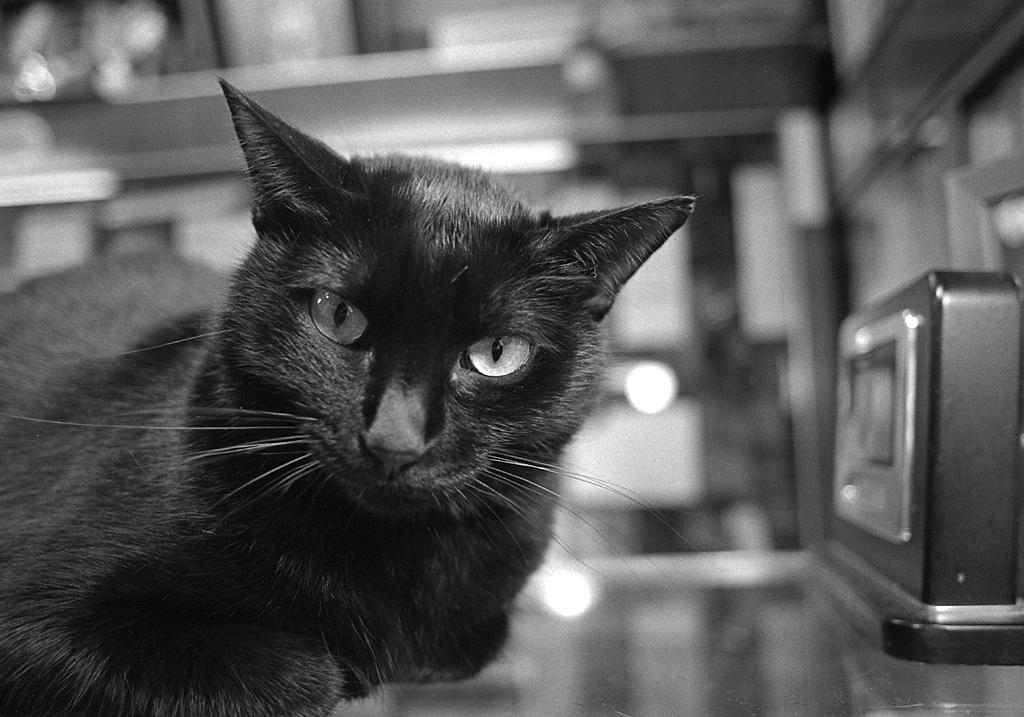What type of location is depicted in the image? The image shows an inner view of a building. Can you describe any objects or animals present in the image? Yes, there is a black cat on a table in the image. How many icicles are hanging from the ceiling in the image? There are no icicles present in the image, as it shows an inner view of a building. 